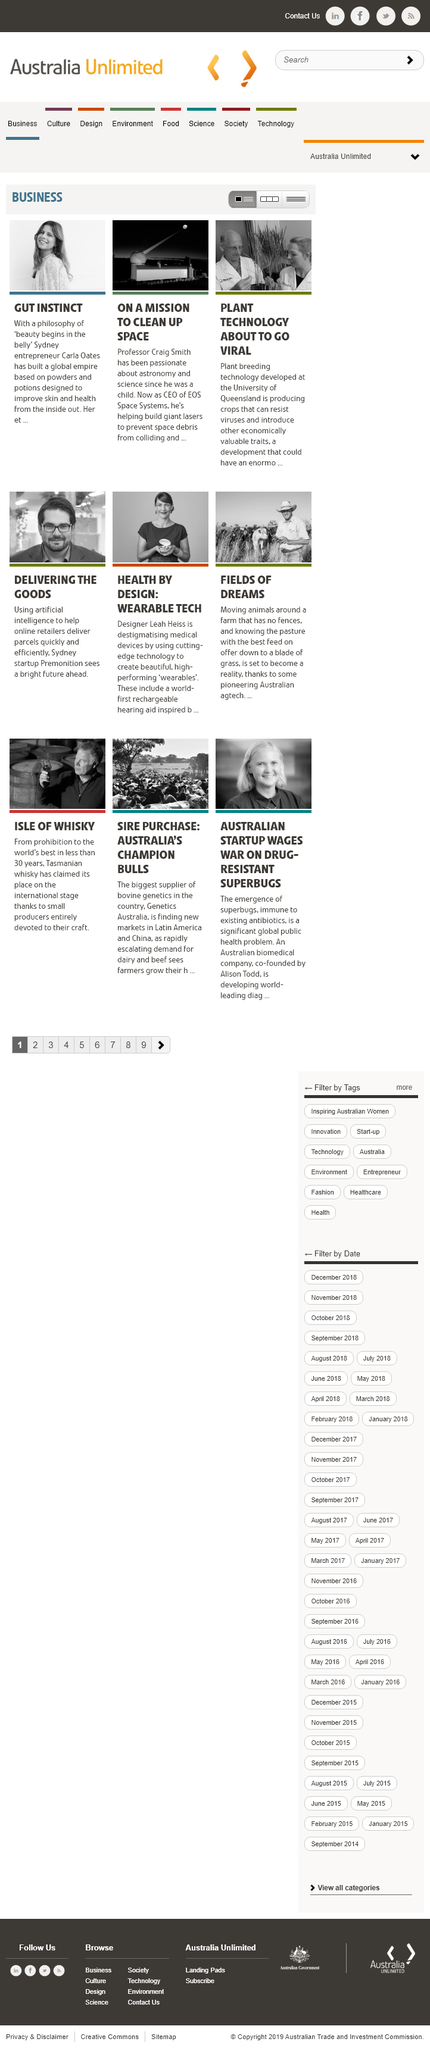Point out several critical features in this image. Plant breeding technology has the ability to produce crops that are resistant to viruses and can introduce economically valuable traits, making it a beneficial technology in the agricultural industry. The CEO of EOS Space Systems is Professor Craig Smith. The top-left image is a portrait of Sydney entrepreneur Carla Oates. 